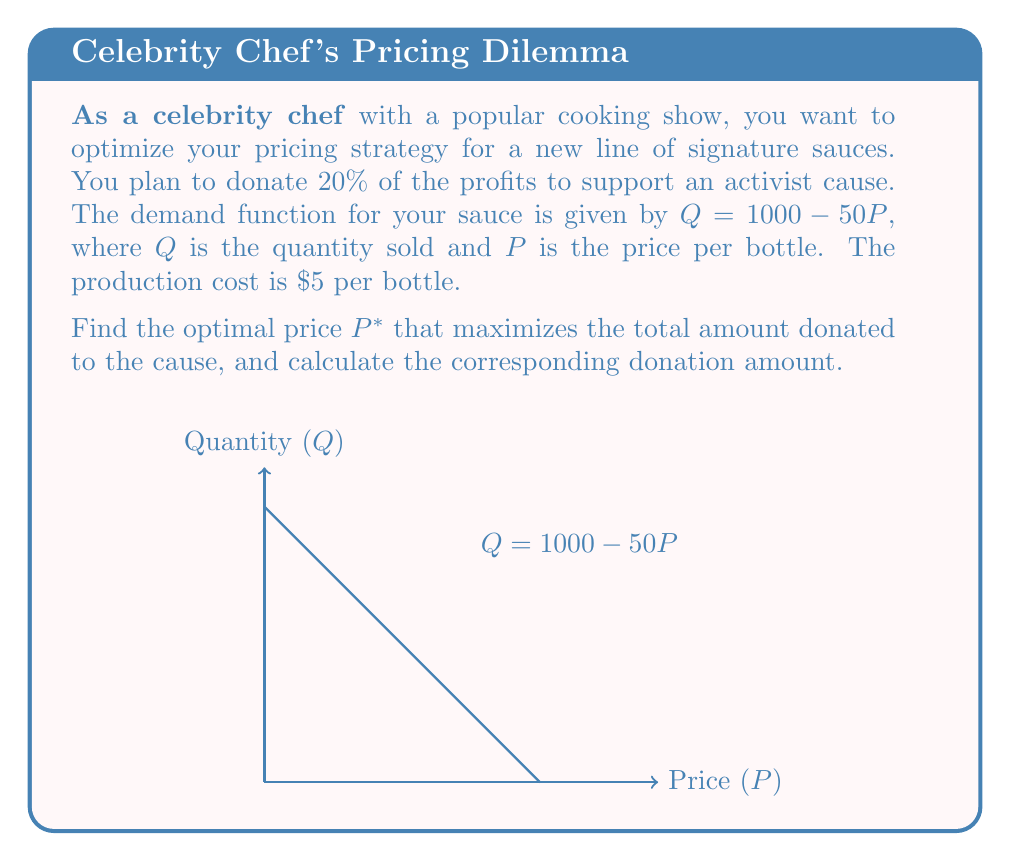Can you solve this math problem? Let's approach this step-by-step:

1) First, we need to express the profit function:
   Revenue = $P \cdot Q = P(1000 - 50P)$
   Cost = $5Q = 5(1000 - 50P)$
   Profit = Revenue - Cost = $P(1000 - 50P) - 5(1000 - 50P)$
   
   $$\text{Profit} = 1000P - 50P^2 - 5000 + 250P = -50P^2 + 1250P - 5000$$

2) The donation is 20% of the profit:
   $$\text{Donation} = 0.2(-50P^2 + 1250P - 5000) = -10P^2 + 250P - 1000$$

3) To find the maximum donation, we differentiate the donation function with respect to P and set it to zero:
   $$\frac{d(\text{Donation})}{dP} = -20P + 250 = 0$$

4) Solve this equation:
   $$-20P + 250 = 0$$
   $$-20P = -250$$
   $$P^* = 12.5$$

5) To confirm this is a maximum, we can check the second derivative is negative:
   $$\frac{d^2(\text{Donation})}{dP^2} = -20 < 0$$

6) Calculate the donation amount at $P^* = 12.5$:
   $$\text{Donation} = -10(12.5)^2 + 250(12.5) - 1000 = -1562.5 + 3125 - 1000 = 562.5$$

Therefore, the optimal price is $\$12.50$ per bottle, which results in a donation of $\$562.50$.
Answer: $P^* = \$12.50$; Donation = $\$562.50$ 